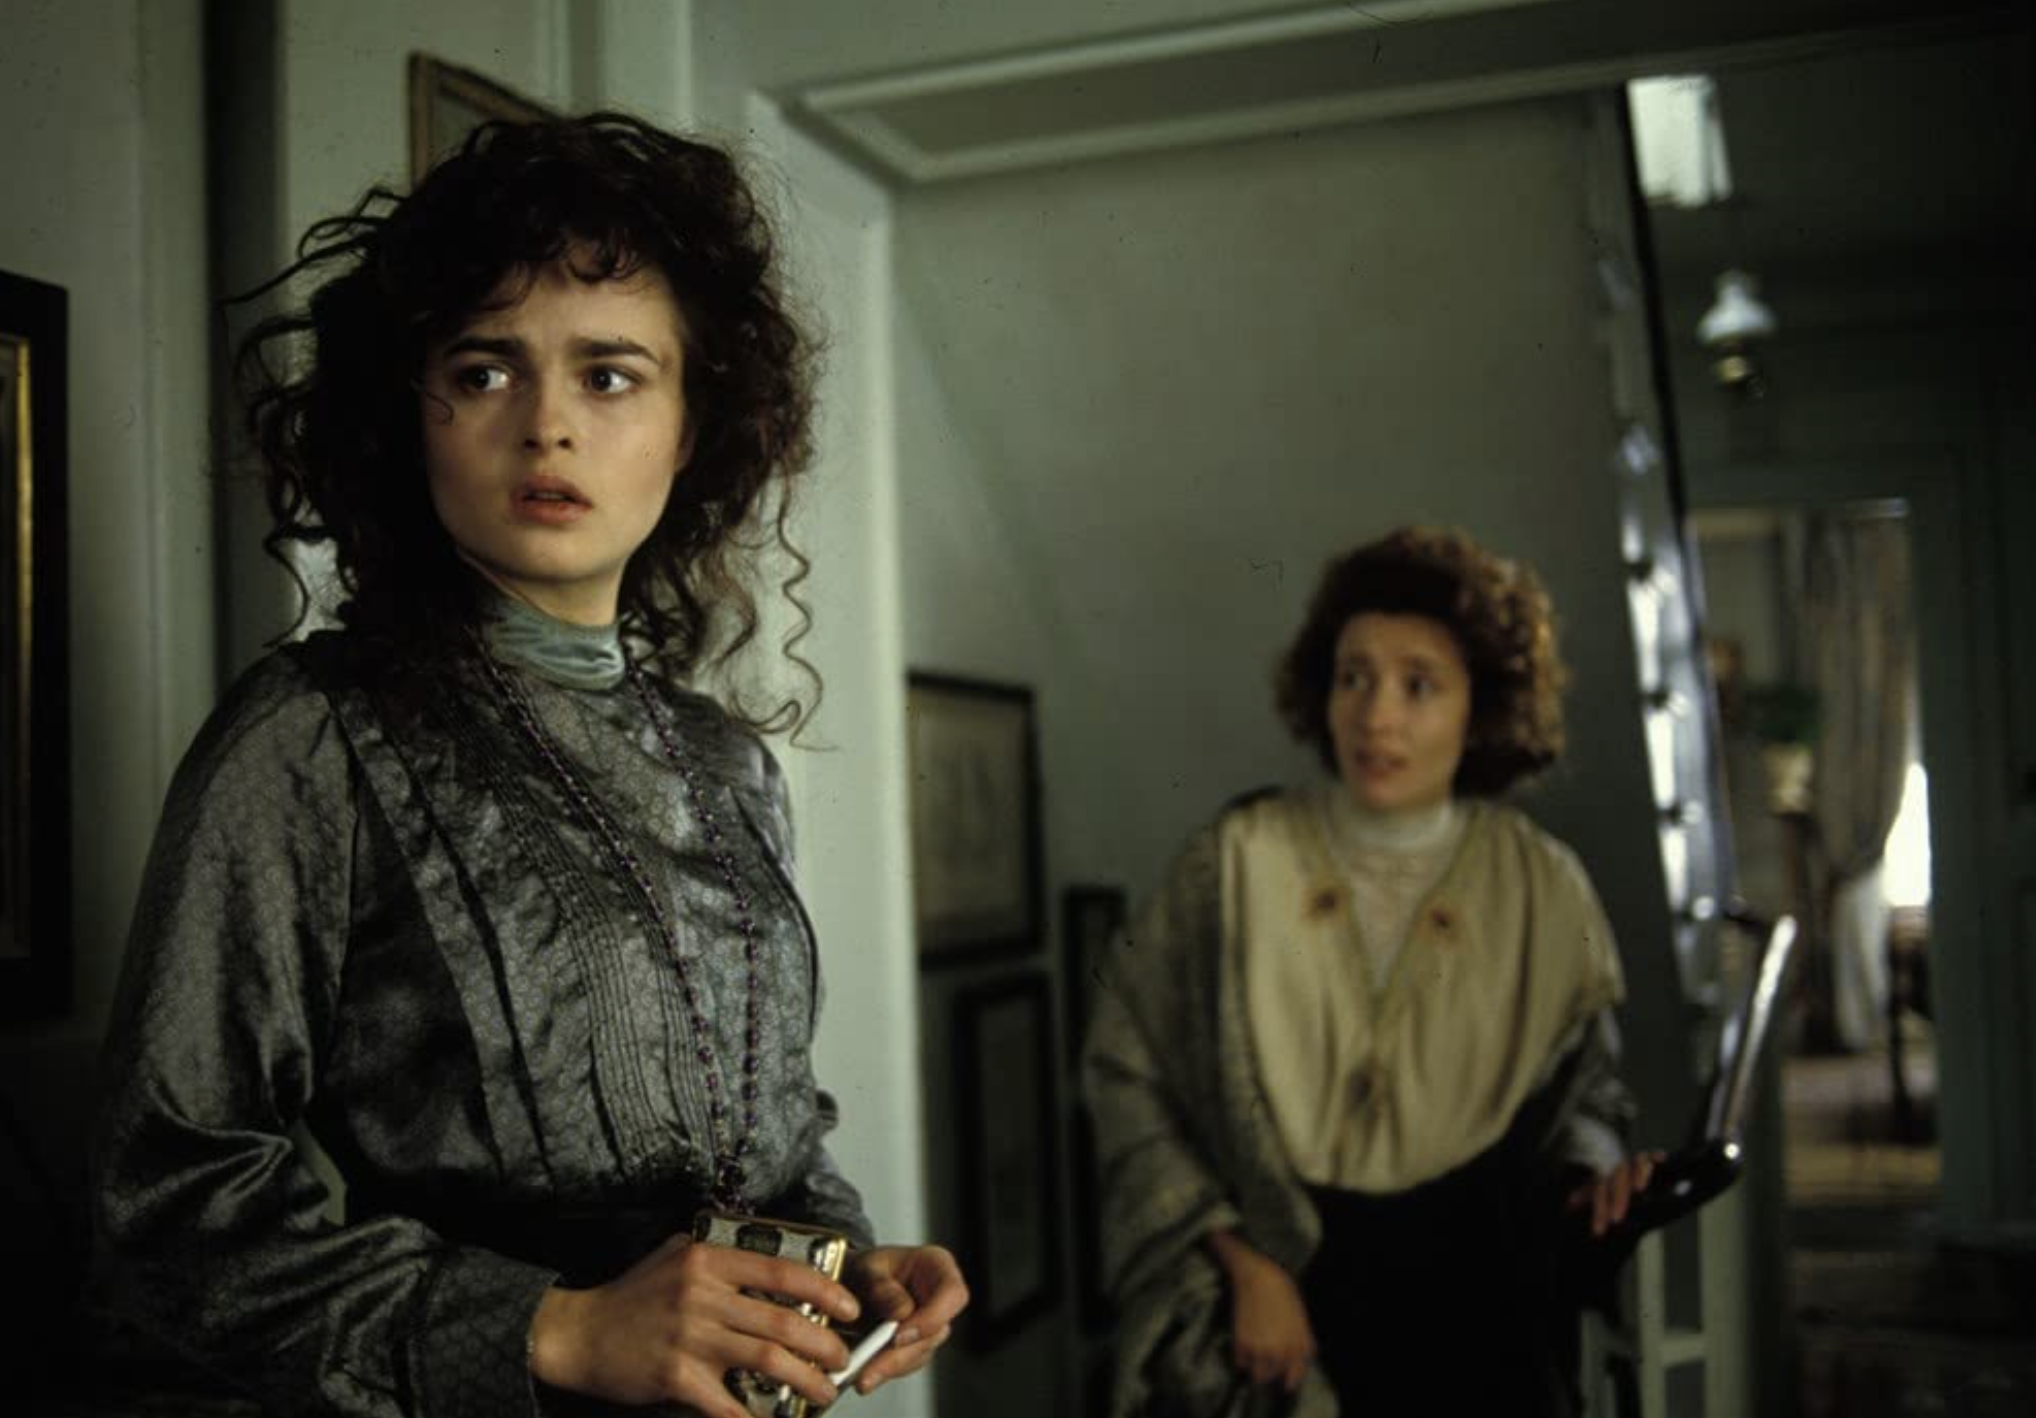What are the key elements in this picture? The photograph presents two individuals in a vintage interior setting, creating an atmosphere charged with emotion. The person in the foreground appears concerned, with her gaze fixed off to the side, holding a piece of jewelry. She is adorned in a period-appropriate attire with a detailed pattern and high collar, suggesting the scene might be set in an earlier time. Her hair showcases voluminous curls, adding to the historical feel of the imagery. In the background, the second individual holds an object that might be a parasol or umbrella, wearing a layered outfit with a high neckline. The fact that one is in the forefront and the other in the door frame can indicate a dynamic of focus and support or contrast. The room has plain light blue walls, and minimal decor, which provides a stark backdrop that throws the emotional state of the characters into relief. 